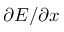<formula> <loc_0><loc_0><loc_500><loc_500>\partial E / \partial x</formula> 